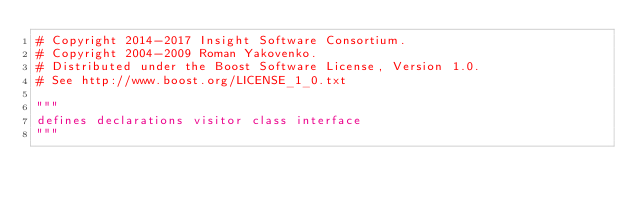<code> <loc_0><loc_0><loc_500><loc_500><_Python_># Copyright 2014-2017 Insight Software Consortium.
# Copyright 2004-2009 Roman Yakovenko.
# Distributed under the Boost Software License, Version 1.0.
# See http://www.boost.org/LICENSE_1_0.txt

"""
defines declarations visitor class interface
"""

</code> 